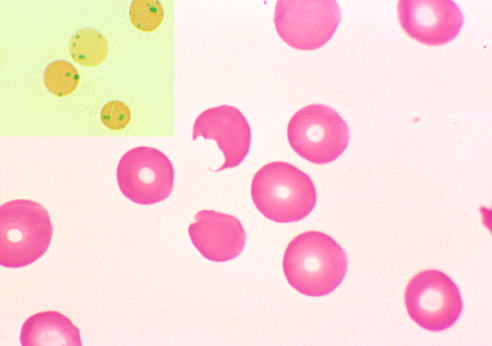what plucks out these inclusions?
Answer the question using a single word or phrase. Splenic macrophages 